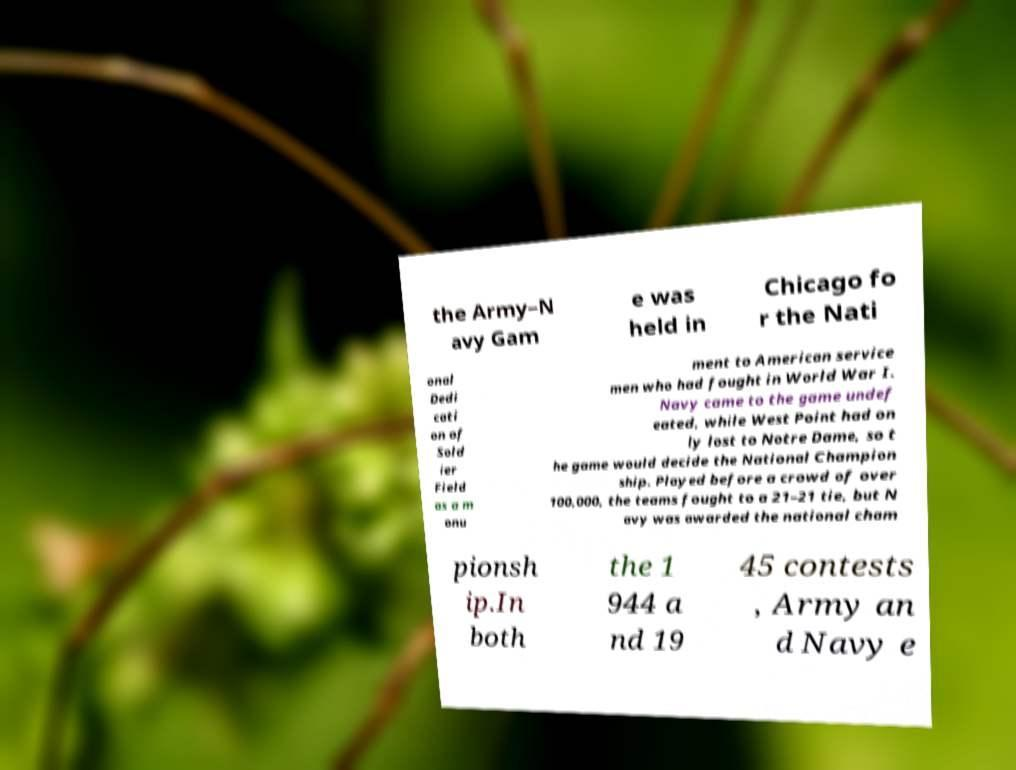What messages or text are displayed in this image? I need them in a readable, typed format. the Army–N avy Gam e was held in Chicago fo r the Nati onal Dedi cati on of Sold ier Field as a m onu ment to American service men who had fought in World War I. Navy came to the game undef eated, while West Point had on ly lost to Notre Dame, so t he game would decide the National Champion ship. Played before a crowd of over 100,000, the teams fought to a 21–21 tie, but N avy was awarded the national cham pionsh ip.In both the 1 944 a nd 19 45 contests , Army an d Navy e 